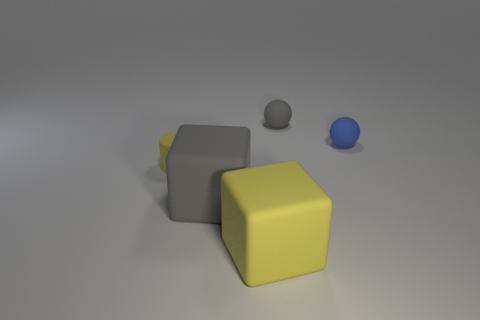Is there a yellow block?
Ensure brevity in your answer.  Yes. What number of other objects are there of the same shape as the small yellow thing?
Provide a succinct answer. 0. Does the tiny rubber thing that is on the right side of the small gray object have the same color as the small thing that is on the left side of the big yellow rubber block?
Provide a succinct answer. No. How big is the gray thing that is in front of the small rubber object that is left of the sphere on the left side of the tiny blue rubber thing?
Make the answer very short. Large. What shape is the rubber object that is both behind the yellow matte cube and in front of the small yellow rubber cylinder?
Provide a short and direct response. Cube. Is the number of big things that are to the right of the tiny gray matte thing the same as the number of small yellow cylinders that are right of the large yellow rubber thing?
Give a very brief answer. Yes. Is there another thing that has the same material as the small yellow object?
Your response must be concise. Yes. Is the block behind the big yellow rubber object made of the same material as the blue thing?
Offer a terse response. Yes. What is the size of the object that is in front of the tiny gray matte thing and behind the yellow matte cylinder?
Offer a terse response. Small. The matte cylinder has what color?
Provide a succinct answer. Yellow. 